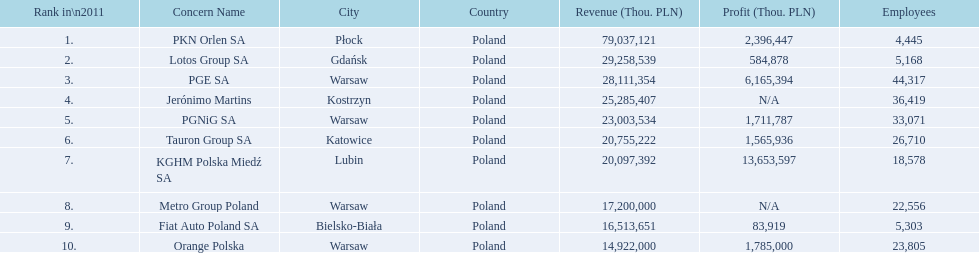Which concern's headquarters are located in warsaw? PGE SA, PGNiG SA, Metro Group Poland. Which of these listed a profit? PGE SA, PGNiG SA. Of these how many employees are in the concern with the lowest profit? 33,071. 